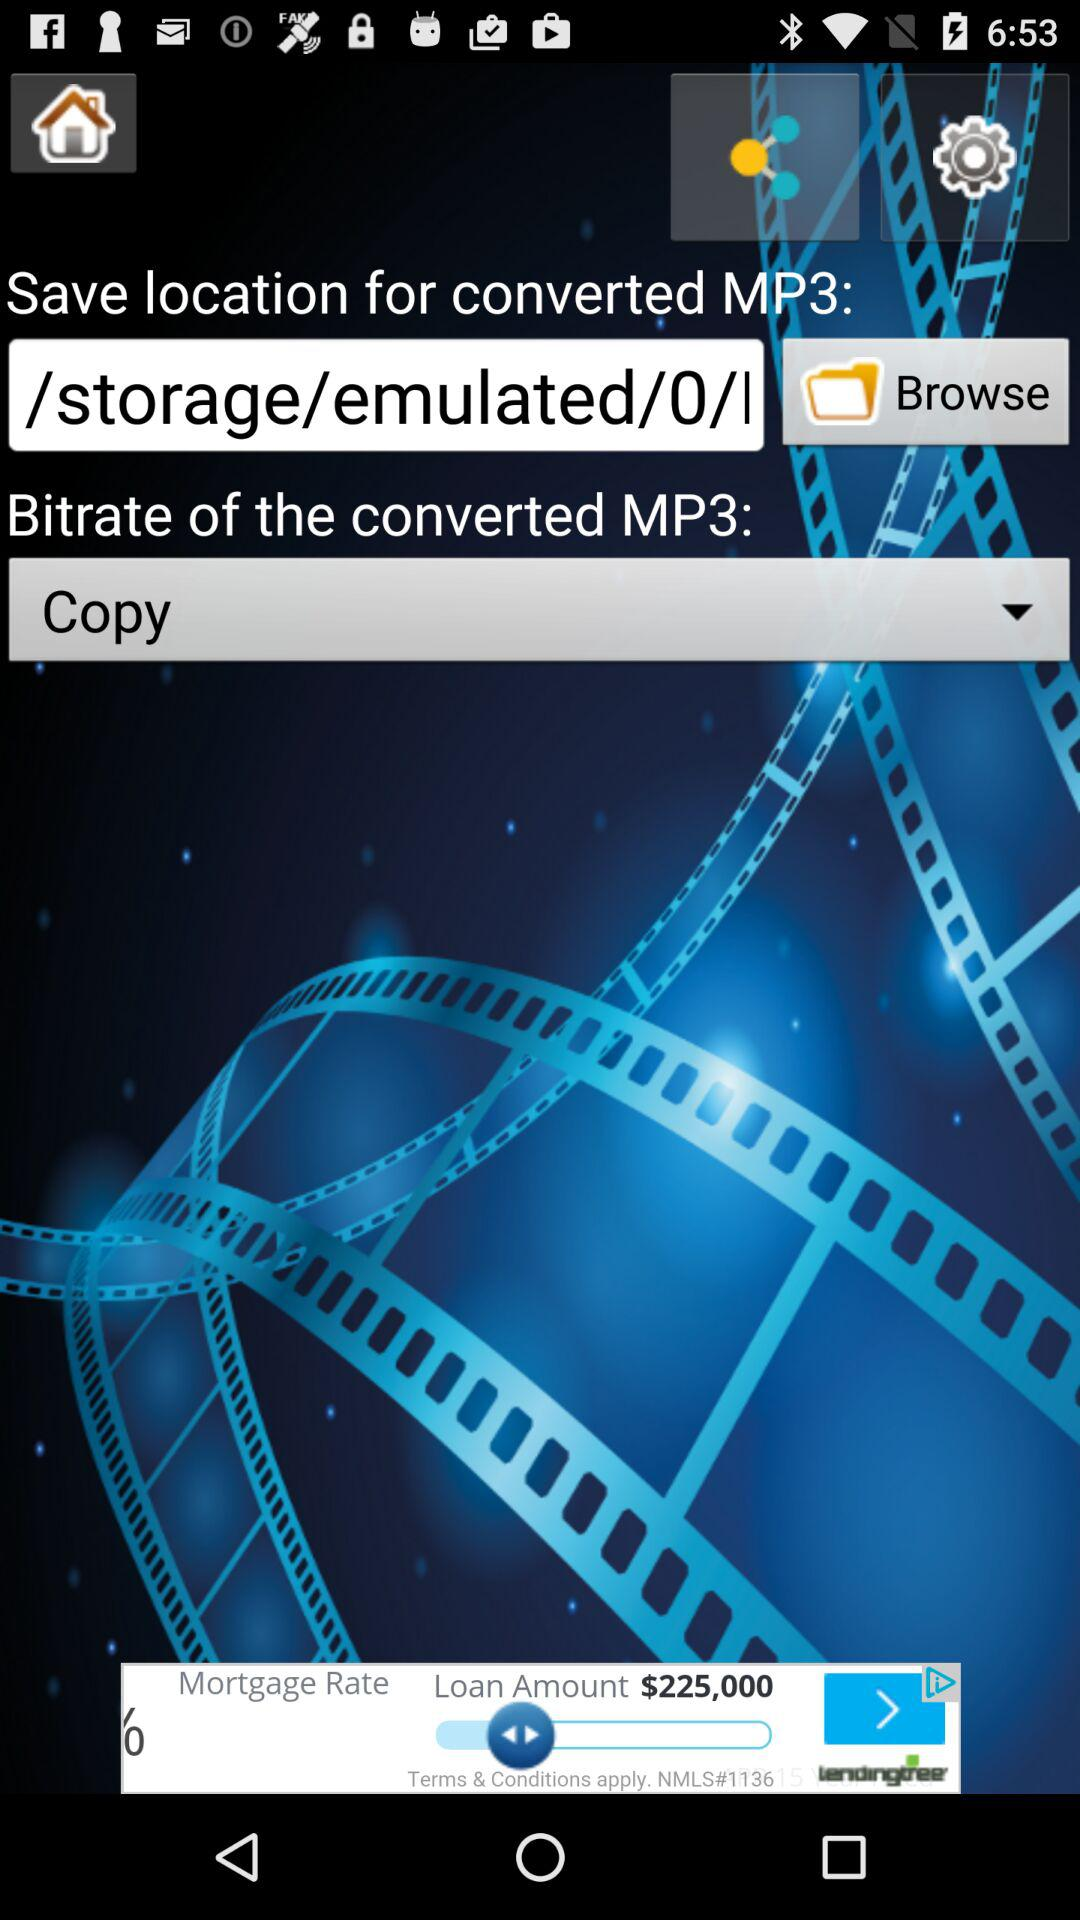What is the save location for converted MP3?
When the provided information is insufficient, respond with <no answer>. <no answer> 